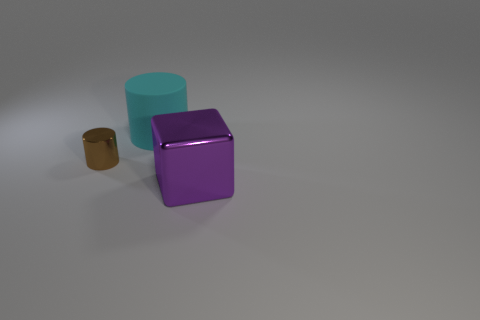What shape is the rubber object that is the same size as the shiny cube?
Keep it short and to the point. Cylinder. There is a metal object that is behind the shiny block; does it have the same size as the object on the right side of the cyan cylinder?
Provide a short and direct response. No. What is the color of the cylinder that is the same material as the purple thing?
Provide a succinct answer. Brown. Is the material of the big thing left of the big purple metal thing the same as the large thing that is in front of the metallic cylinder?
Your response must be concise. No. Are there any metallic cubes that have the same size as the metallic cylinder?
Offer a terse response. No. What is the size of the object in front of the metallic object that is on the left side of the big purple metallic cube?
Provide a succinct answer. Large. There is a metal thing in front of the cylinder in front of the cyan thing; what is its shape?
Offer a very short reply. Cube. How many small brown spheres have the same material as the small brown thing?
Make the answer very short. 0. There is a purple object in front of the brown metal thing; what material is it?
Keep it short and to the point. Metal. The object that is behind the thing on the left side of the large object on the left side of the big purple object is what shape?
Your answer should be compact. Cylinder. 